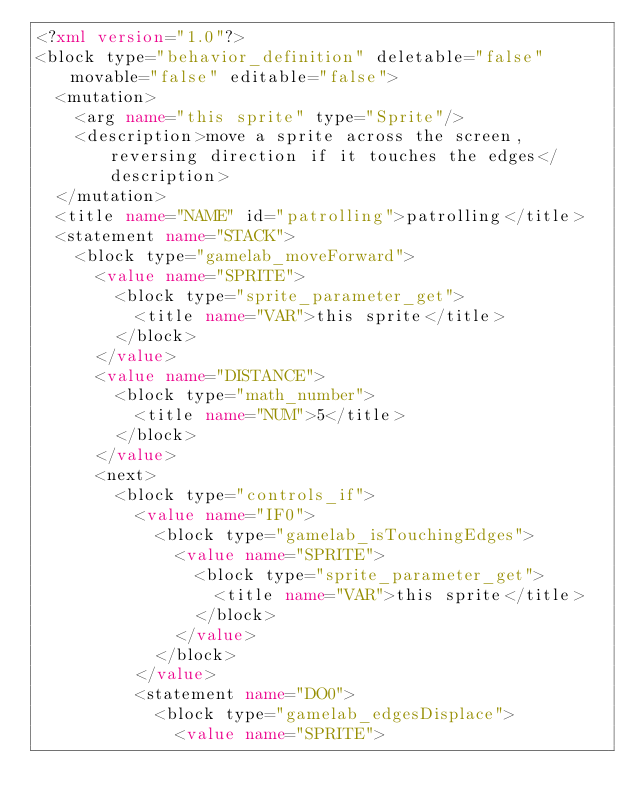Convert code to text. <code><loc_0><loc_0><loc_500><loc_500><_XML_><?xml version="1.0"?>
<block type="behavior_definition" deletable="false" movable="false" editable="false">
  <mutation>
    <arg name="this sprite" type="Sprite"/>
    <description>move a sprite across the screen, reversing direction if it touches the edges</description>
  </mutation>
  <title name="NAME" id="patrolling">patrolling</title>
  <statement name="STACK">
    <block type="gamelab_moveForward">
      <value name="SPRITE">
        <block type="sprite_parameter_get">
          <title name="VAR">this sprite</title>
        </block>
      </value>
      <value name="DISTANCE">
        <block type="math_number">
          <title name="NUM">5</title>
        </block>
      </value>
      <next>
        <block type="controls_if">
          <value name="IF0">
            <block type="gamelab_isTouchingEdges">
              <value name="SPRITE">
                <block type="sprite_parameter_get">
                  <title name="VAR">this sprite</title>
                </block>
              </value>
            </block>
          </value>
          <statement name="DO0">
            <block type="gamelab_edgesDisplace">
              <value name="SPRITE"></code> 